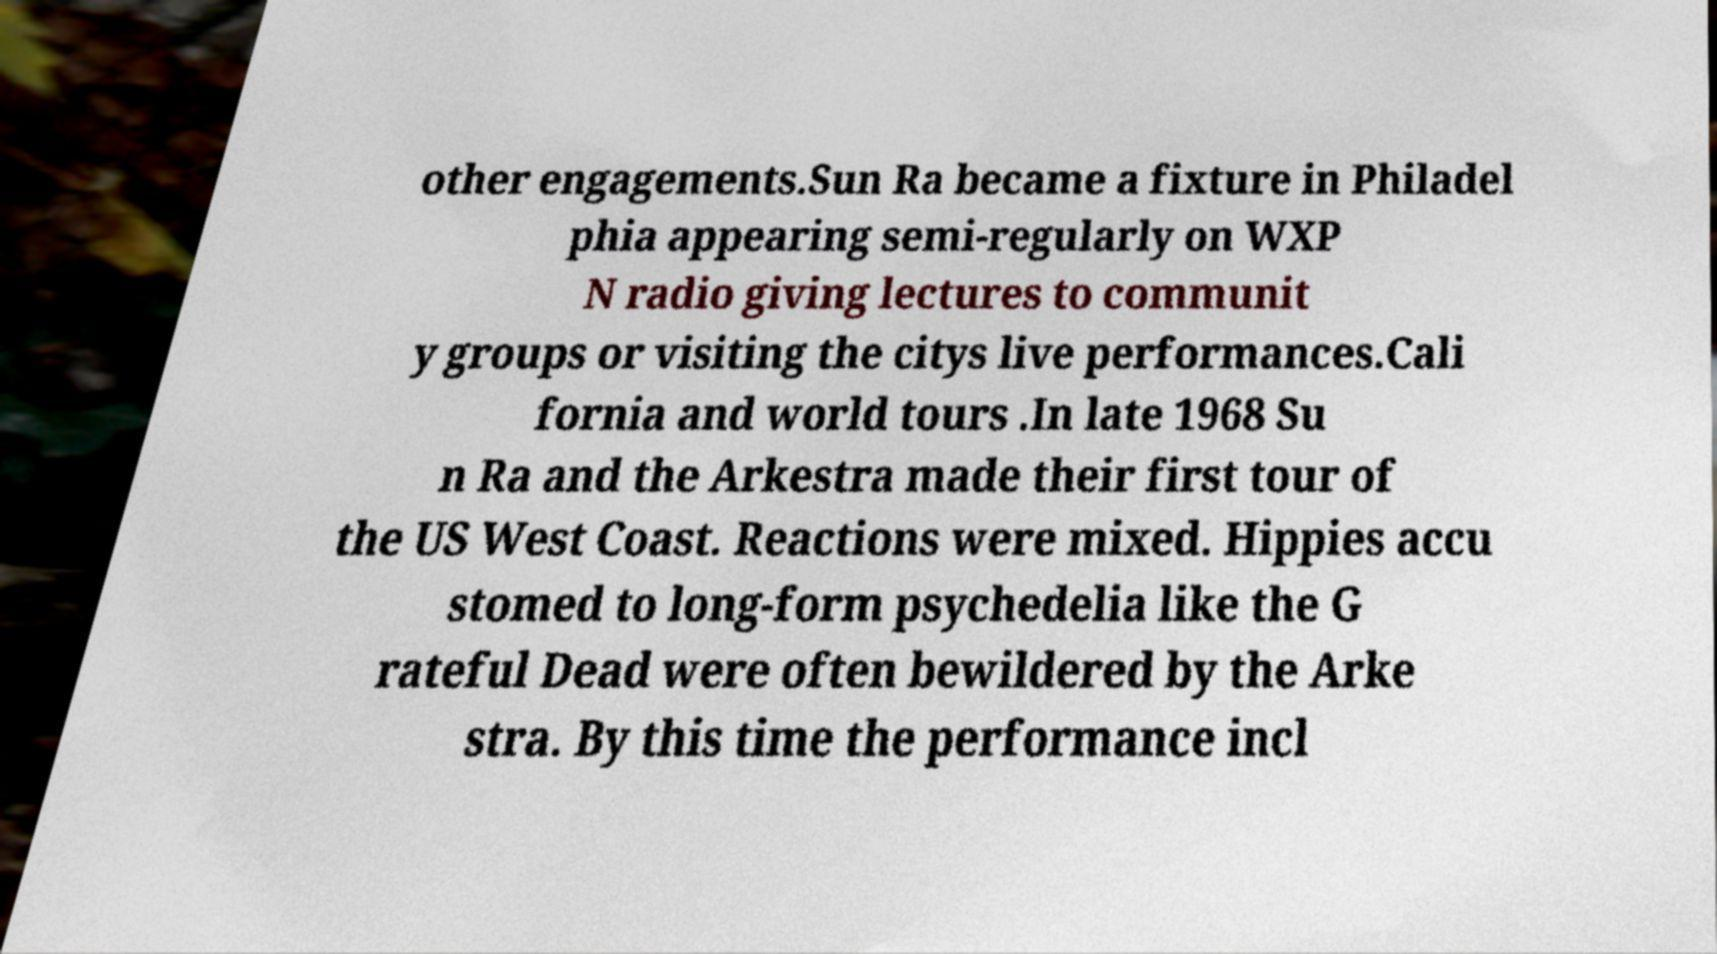For documentation purposes, I need the text within this image transcribed. Could you provide that? other engagements.Sun Ra became a fixture in Philadel phia appearing semi-regularly on WXP N radio giving lectures to communit y groups or visiting the citys live performances.Cali fornia and world tours .In late 1968 Su n Ra and the Arkestra made their first tour of the US West Coast. Reactions were mixed. Hippies accu stomed to long-form psychedelia like the G rateful Dead were often bewildered by the Arke stra. By this time the performance incl 